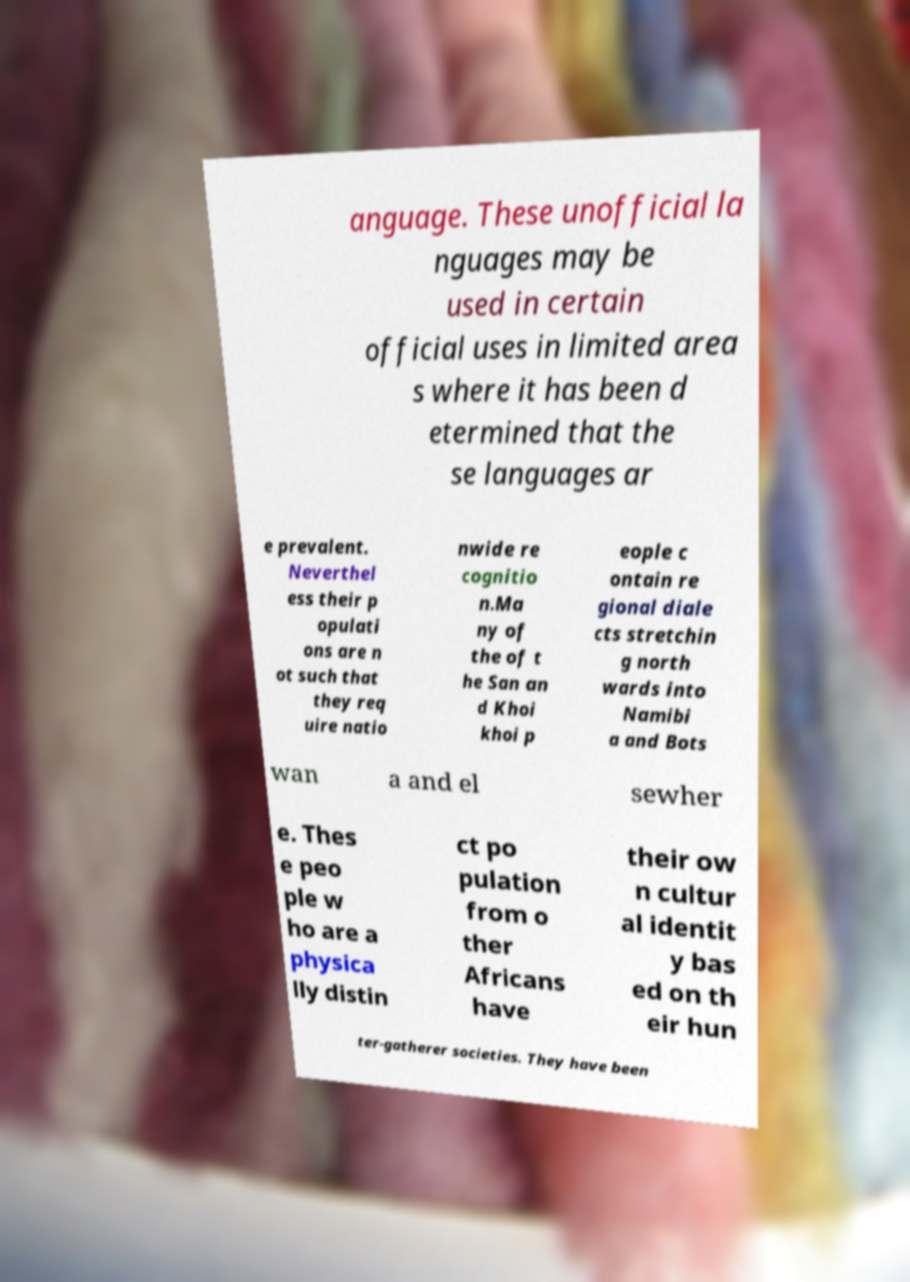Could you extract and type out the text from this image? anguage. These unofficial la nguages may be used in certain official uses in limited area s where it has been d etermined that the se languages ar e prevalent. Neverthel ess their p opulati ons are n ot such that they req uire natio nwide re cognitio n.Ma ny of the of t he San an d Khoi khoi p eople c ontain re gional diale cts stretchin g north wards into Namibi a and Bots wan a and el sewher e. Thes e peo ple w ho are a physica lly distin ct po pulation from o ther Africans have their ow n cultur al identit y bas ed on th eir hun ter-gatherer societies. They have been 